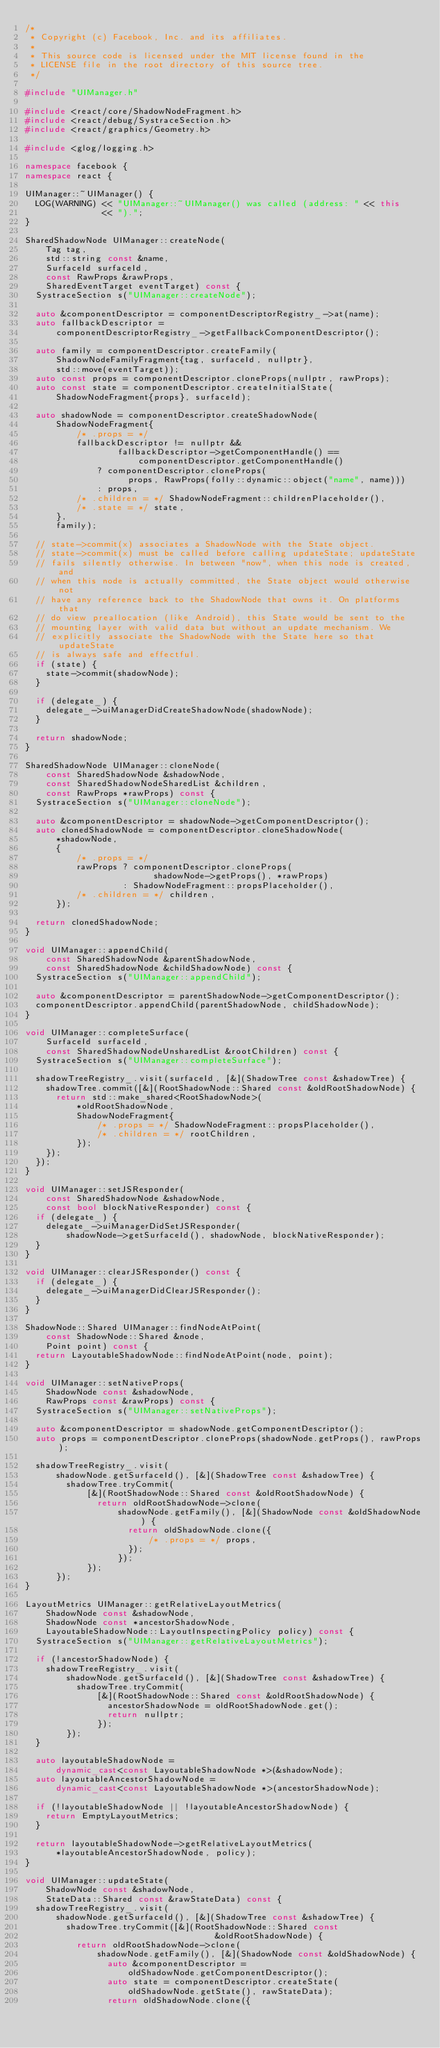<code> <loc_0><loc_0><loc_500><loc_500><_C++_>/*
 * Copyright (c) Facebook, Inc. and its affiliates.
 *
 * This source code is licensed under the MIT license found in the
 * LICENSE file in the root directory of this source tree.
 */

#include "UIManager.h"

#include <react/core/ShadowNodeFragment.h>
#include <react/debug/SystraceSection.h>
#include <react/graphics/Geometry.h>

#include <glog/logging.h>

namespace facebook {
namespace react {

UIManager::~UIManager() {
  LOG(WARNING) << "UIManager::~UIManager() was called (address: " << this
               << ").";
}

SharedShadowNode UIManager::createNode(
    Tag tag,
    std::string const &name,
    SurfaceId surfaceId,
    const RawProps &rawProps,
    SharedEventTarget eventTarget) const {
  SystraceSection s("UIManager::createNode");

  auto &componentDescriptor = componentDescriptorRegistry_->at(name);
  auto fallbackDescriptor =
      componentDescriptorRegistry_->getFallbackComponentDescriptor();

  auto family = componentDescriptor.createFamily(
      ShadowNodeFamilyFragment{tag, surfaceId, nullptr},
      std::move(eventTarget));
  auto const props = componentDescriptor.cloneProps(nullptr, rawProps);
  auto const state = componentDescriptor.createInitialState(
      ShadowNodeFragment{props}, surfaceId);

  auto shadowNode = componentDescriptor.createShadowNode(
      ShadowNodeFragment{
          /* .props = */
          fallbackDescriptor != nullptr &&
                  fallbackDescriptor->getComponentHandle() ==
                      componentDescriptor.getComponentHandle()
              ? componentDescriptor.cloneProps(
                    props, RawProps(folly::dynamic::object("name", name)))
              : props,
          /* .children = */ ShadowNodeFragment::childrenPlaceholder(),
          /* .state = */ state,
      },
      family);

  // state->commit(x) associates a ShadowNode with the State object.
  // state->commit(x) must be called before calling updateState; updateState
  // fails silently otherwise. In between "now", when this node is created, and
  // when this node is actually committed, the State object would otherwise not
  // have any reference back to the ShadowNode that owns it. On platforms that
  // do view preallocation (like Android), this State would be sent to the
  // mounting layer with valid data but without an update mechanism. We
  // explicitly associate the ShadowNode with the State here so that updateState
  // is always safe and effectful.
  if (state) {
    state->commit(shadowNode);
  }

  if (delegate_) {
    delegate_->uiManagerDidCreateShadowNode(shadowNode);
  }

  return shadowNode;
}

SharedShadowNode UIManager::cloneNode(
    const SharedShadowNode &shadowNode,
    const SharedShadowNodeSharedList &children,
    const RawProps *rawProps) const {
  SystraceSection s("UIManager::cloneNode");

  auto &componentDescriptor = shadowNode->getComponentDescriptor();
  auto clonedShadowNode = componentDescriptor.cloneShadowNode(
      *shadowNode,
      {
          /* .props = */
          rawProps ? componentDescriptor.cloneProps(
                         shadowNode->getProps(), *rawProps)
                   : ShadowNodeFragment::propsPlaceholder(),
          /* .children = */ children,
      });

  return clonedShadowNode;
}

void UIManager::appendChild(
    const SharedShadowNode &parentShadowNode,
    const SharedShadowNode &childShadowNode) const {
  SystraceSection s("UIManager::appendChild");

  auto &componentDescriptor = parentShadowNode->getComponentDescriptor();
  componentDescriptor.appendChild(parentShadowNode, childShadowNode);
}

void UIManager::completeSurface(
    SurfaceId surfaceId,
    const SharedShadowNodeUnsharedList &rootChildren) const {
  SystraceSection s("UIManager::completeSurface");

  shadowTreeRegistry_.visit(surfaceId, [&](ShadowTree const &shadowTree) {
    shadowTree.commit([&](RootShadowNode::Shared const &oldRootShadowNode) {
      return std::make_shared<RootShadowNode>(
          *oldRootShadowNode,
          ShadowNodeFragment{
              /* .props = */ ShadowNodeFragment::propsPlaceholder(),
              /* .children = */ rootChildren,
          });
    });
  });
}

void UIManager::setJSResponder(
    const SharedShadowNode &shadowNode,
    const bool blockNativeResponder) const {
  if (delegate_) {
    delegate_->uiManagerDidSetJSResponder(
        shadowNode->getSurfaceId(), shadowNode, blockNativeResponder);
  }
}

void UIManager::clearJSResponder() const {
  if (delegate_) {
    delegate_->uiManagerDidClearJSResponder();
  }
}

ShadowNode::Shared UIManager::findNodeAtPoint(
    const ShadowNode::Shared &node,
    Point point) const {
  return LayoutableShadowNode::findNodeAtPoint(node, point);
}

void UIManager::setNativeProps(
    ShadowNode const &shadowNode,
    RawProps const &rawProps) const {
  SystraceSection s("UIManager::setNativeProps");

  auto &componentDescriptor = shadowNode.getComponentDescriptor();
  auto props = componentDescriptor.cloneProps(shadowNode.getProps(), rawProps);

  shadowTreeRegistry_.visit(
      shadowNode.getSurfaceId(), [&](ShadowTree const &shadowTree) {
        shadowTree.tryCommit(
            [&](RootShadowNode::Shared const &oldRootShadowNode) {
              return oldRootShadowNode->clone(
                  shadowNode.getFamily(), [&](ShadowNode const &oldShadowNode) {
                    return oldShadowNode.clone({
                        /* .props = */ props,
                    });
                  });
            });
      });
}

LayoutMetrics UIManager::getRelativeLayoutMetrics(
    ShadowNode const &shadowNode,
    ShadowNode const *ancestorShadowNode,
    LayoutableShadowNode::LayoutInspectingPolicy policy) const {
  SystraceSection s("UIManager::getRelativeLayoutMetrics");

  if (!ancestorShadowNode) {
    shadowTreeRegistry_.visit(
        shadowNode.getSurfaceId(), [&](ShadowTree const &shadowTree) {
          shadowTree.tryCommit(
              [&](RootShadowNode::Shared const &oldRootShadowNode) {
                ancestorShadowNode = oldRootShadowNode.get();
                return nullptr;
              });
        });
  }

  auto layoutableShadowNode =
      dynamic_cast<const LayoutableShadowNode *>(&shadowNode);
  auto layoutableAncestorShadowNode =
      dynamic_cast<const LayoutableShadowNode *>(ancestorShadowNode);

  if (!layoutableShadowNode || !layoutableAncestorShadowNode) {
    return EmptyLayoutMetrics;
  }

  return layoutableShadowNode->getRelativeLayoutMetrics(
      *layoutableAncestorShadowNode, policy);
}

void UIManager::updateState(
    ShadowNode const &shadowNode,
    StateData::Shared const &rawStateData) const {
  shadowTreeRegistry_.visit(
      shadowNode.getSurfaceId(), [&](ShadowTree const &shadowTree) {
        shadowTree.tryCommit([&](RootShadowNode::Shared const
                                     &oldRootShadowNode) {
          return oldRootShadowNode->clone(
              shadowNode.getFamily(), [&](ShadowNode const &oldShadowNode) {
                auto &componentDescriptor =
                    oldShadowNode.getComponentDescriptor();
                auto state = componentDescriptor.createState(
                    oldShadowNode.getState(), rawStateData);
                return oldShadowNode.clone({</code> 